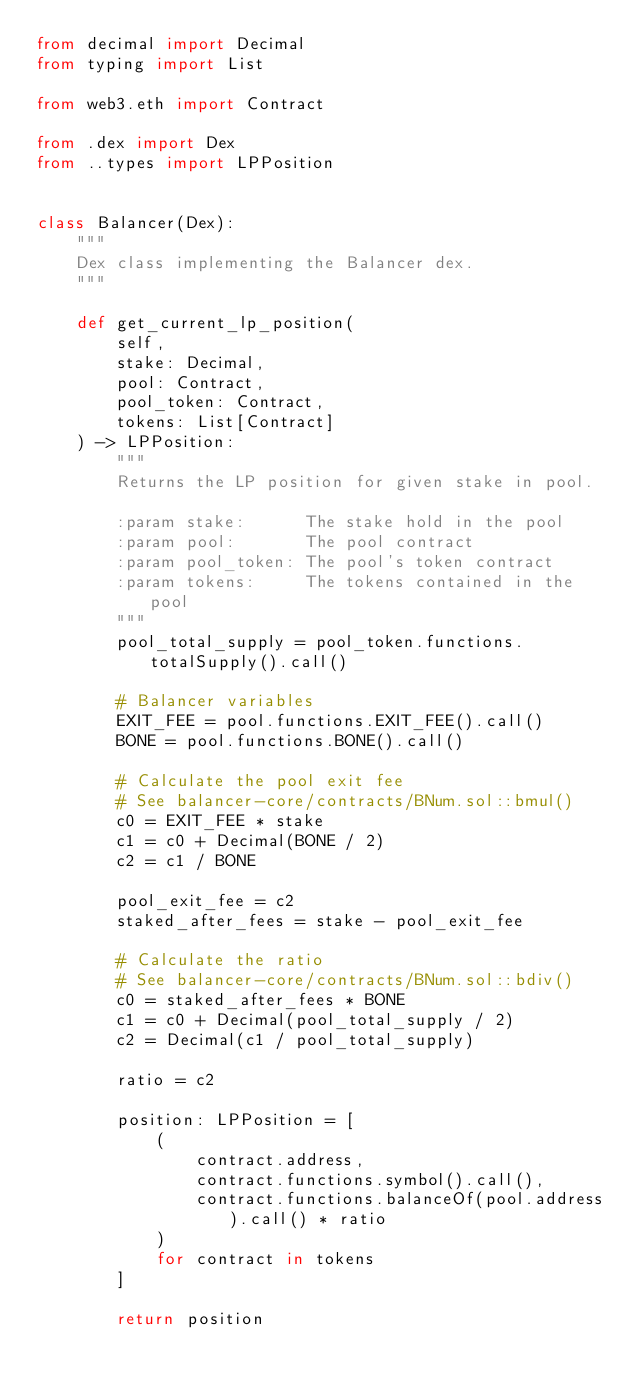<code> <loc_0><loc_0><loc_500><loc_500><_Python_>from decimal import Decimal
from typing import List

from web3.eth import Contract

from .dex import Dex
from ..types import LPPosition


class Balancer(Dex):
    """
    Dex class implementing the Balancer dex.
    """

    def get_current_lp_position(
        self,
        stake: Decimal,
        pool: Contract,
        pool_token: Contract,
        tokens: List[Contract]
    ) -> LPPosition:
        """
        Returns the LP position for given stake in pool.

        :param stake:      The stake hold in the pool
        :param pool:       The pool contract
        :param pool_token: The pool's token contract
        :param tokens:     The tokens contained in the pool
        """
        pool_total_supply = pool_token.functions.totalSupply().call()

        # Balancer variables
        EXIT_FEE = pool.functions.EXIT_FEE().call()
        BONE = pool.functions.BONE().call()

        # Calculate the pool exit fee
        # See balancer-core/contracts/BNum.sol::bmul()
        c0 = EXIT_FEE * stake
        c1 = c0 + Decimal(BONE / 2)
        c2 = c1 / BONE

        pool_exit_fee = c2
        staked_after_fees = stake - pool_exit_fee

        # Calculate the ratio
        # See balancer-core/contracts/BNum.sol::bdiv()
        c0 = staked_after_fees * BONE
        c1 = c0 + Decimal(pool_total_supply / 2)
        c2 = Decimal(c1 / pool_total_supply)

        ratio = c2

        position: LPPosition = [
            (
                contract.address,
                contract.functions.symbol().call(),
                contract.functions.balanceOf(pool.address).call() * ratio
            )
            for contract in tokens
        ]

        return position
</code> 